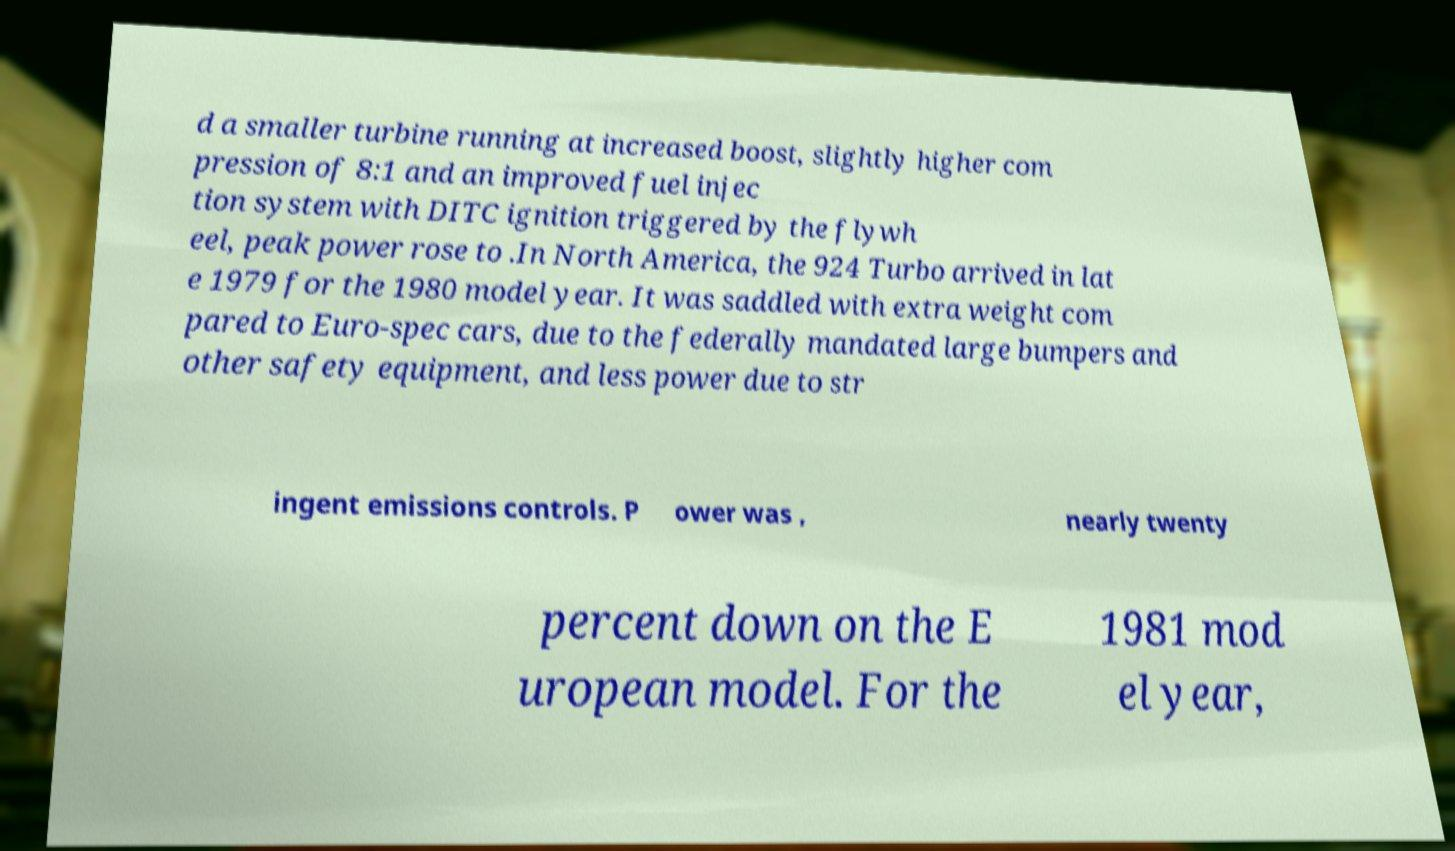For documentation purposes, I need the text within this image transcribed. Could you provide that? d a smaller turbine running at increased boost, slightly higher com pression of 8:1 and an improved fuel injec tion system with DITC ignition triggered by the flywh eel, peak power rose to .In North America, the 924 Turbo arrived in lat e 1979 for the 1980 model year. It was saddled with extra weight com pared to Euro-spec cars, due to the federally mandated large bumpers and other safety equipment, and less power due to str ingent emissions controls. P ower was , nearly twenty percent down on the E uropean model. For the 1981 mod el year, 